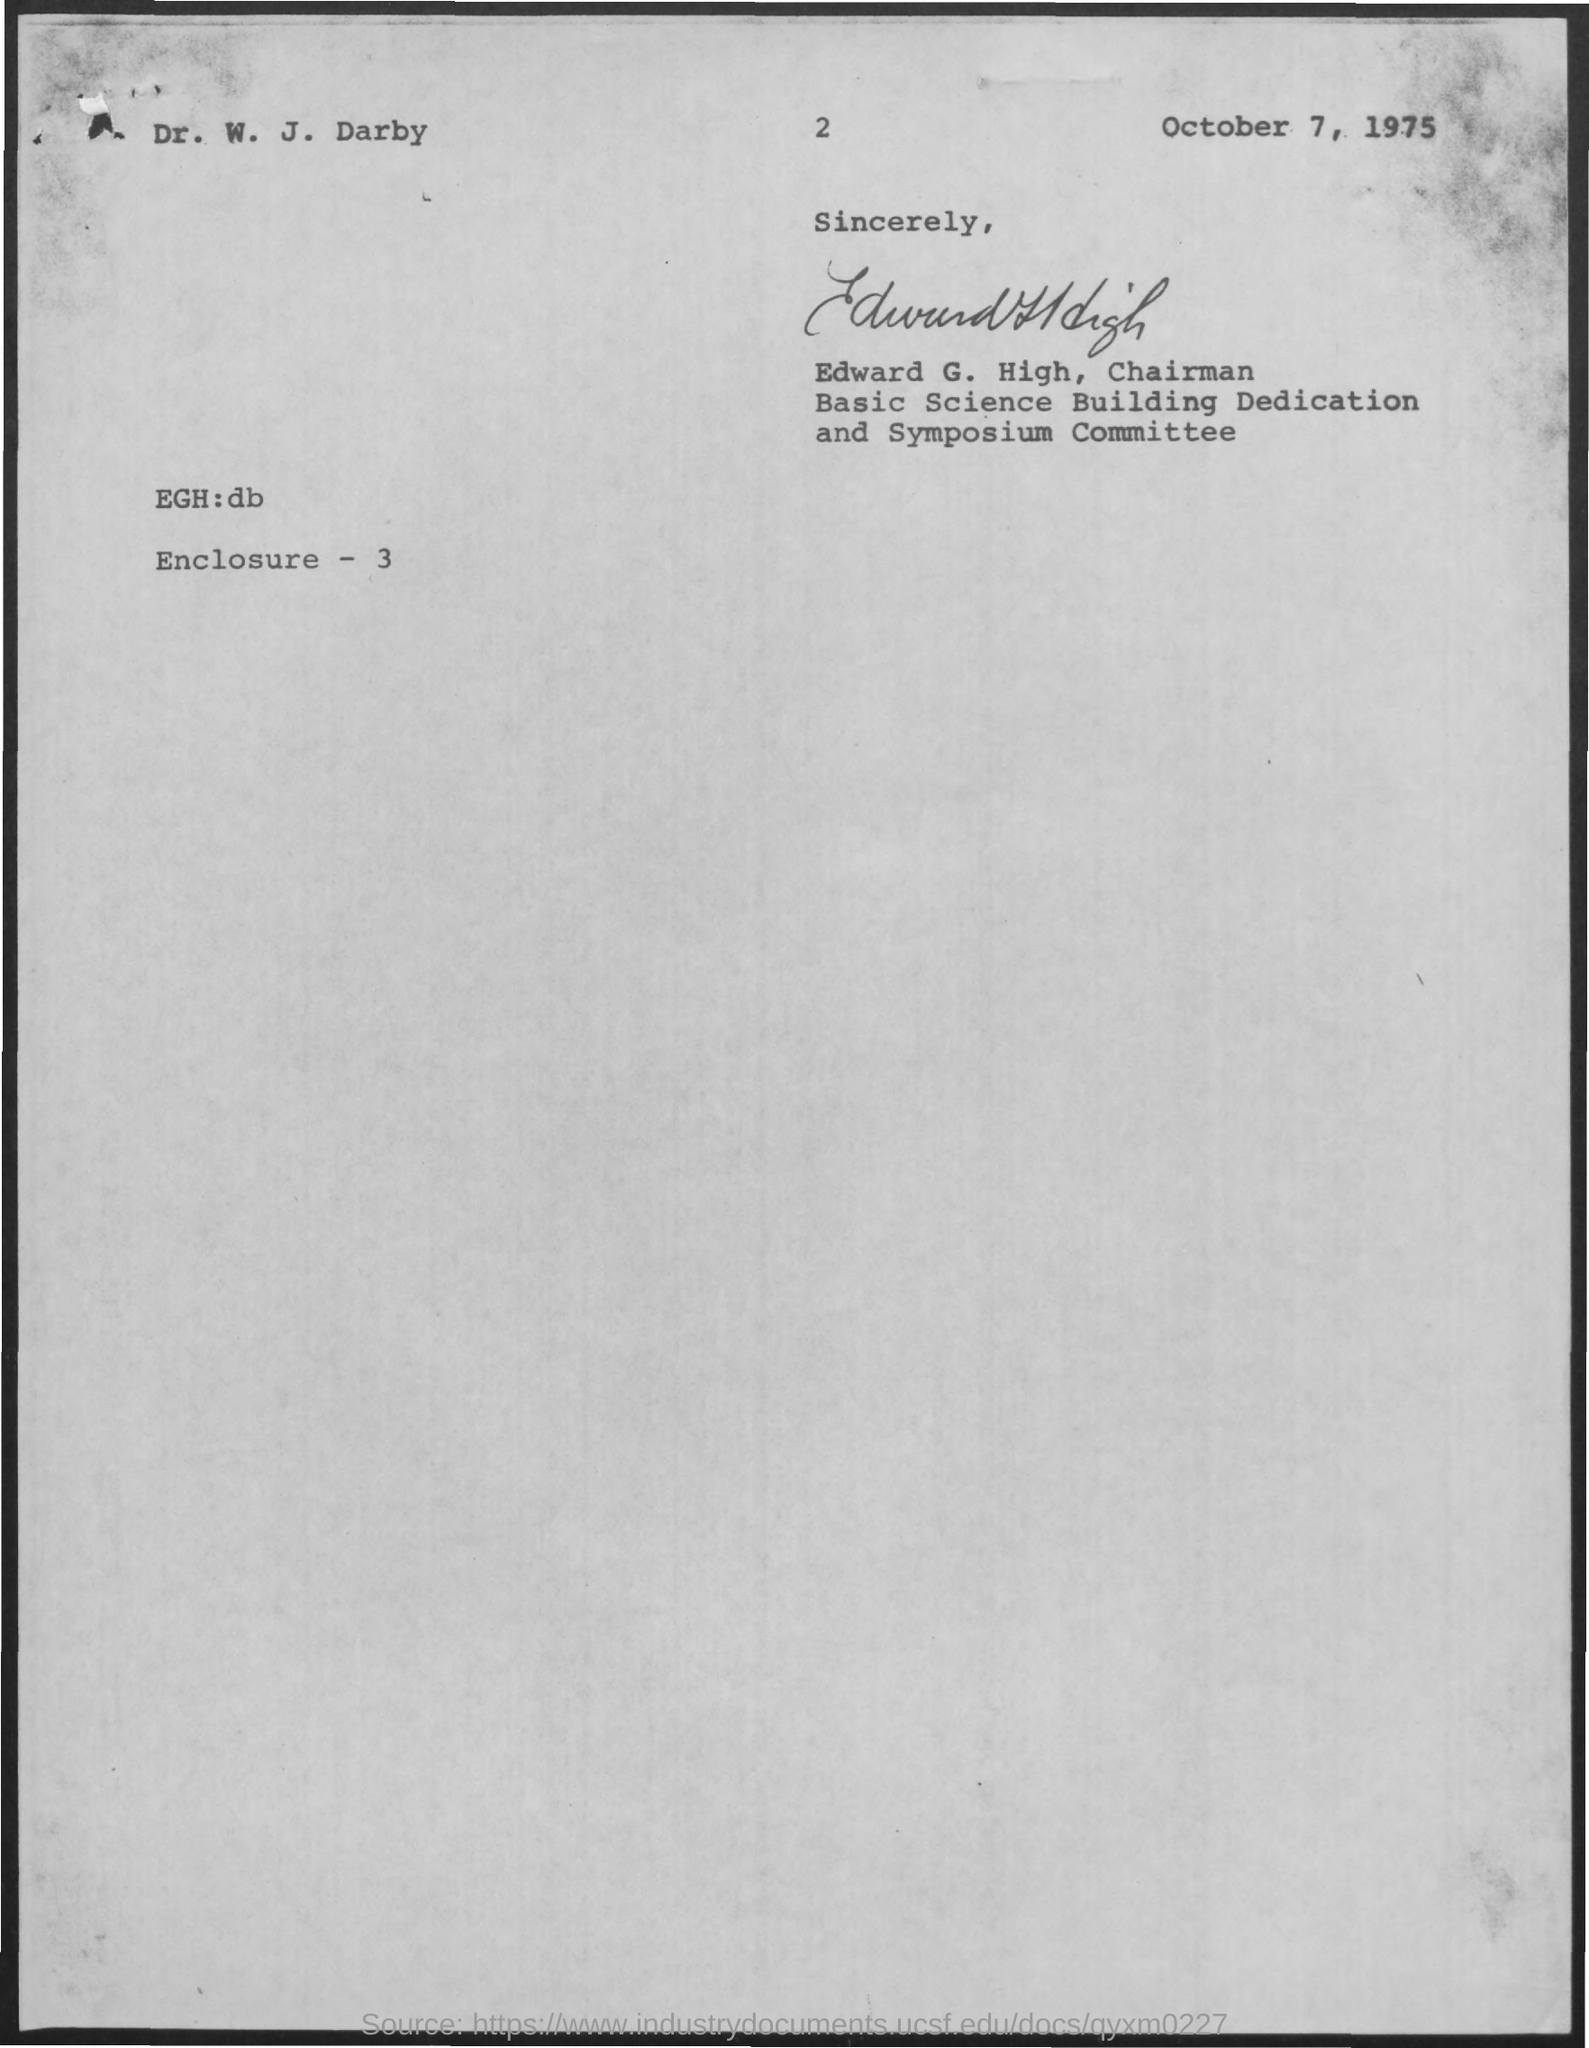Point out several critical features in this image. The letter has been signed by Edward G. High. The letter dated October 7, 1975, has been provided. 